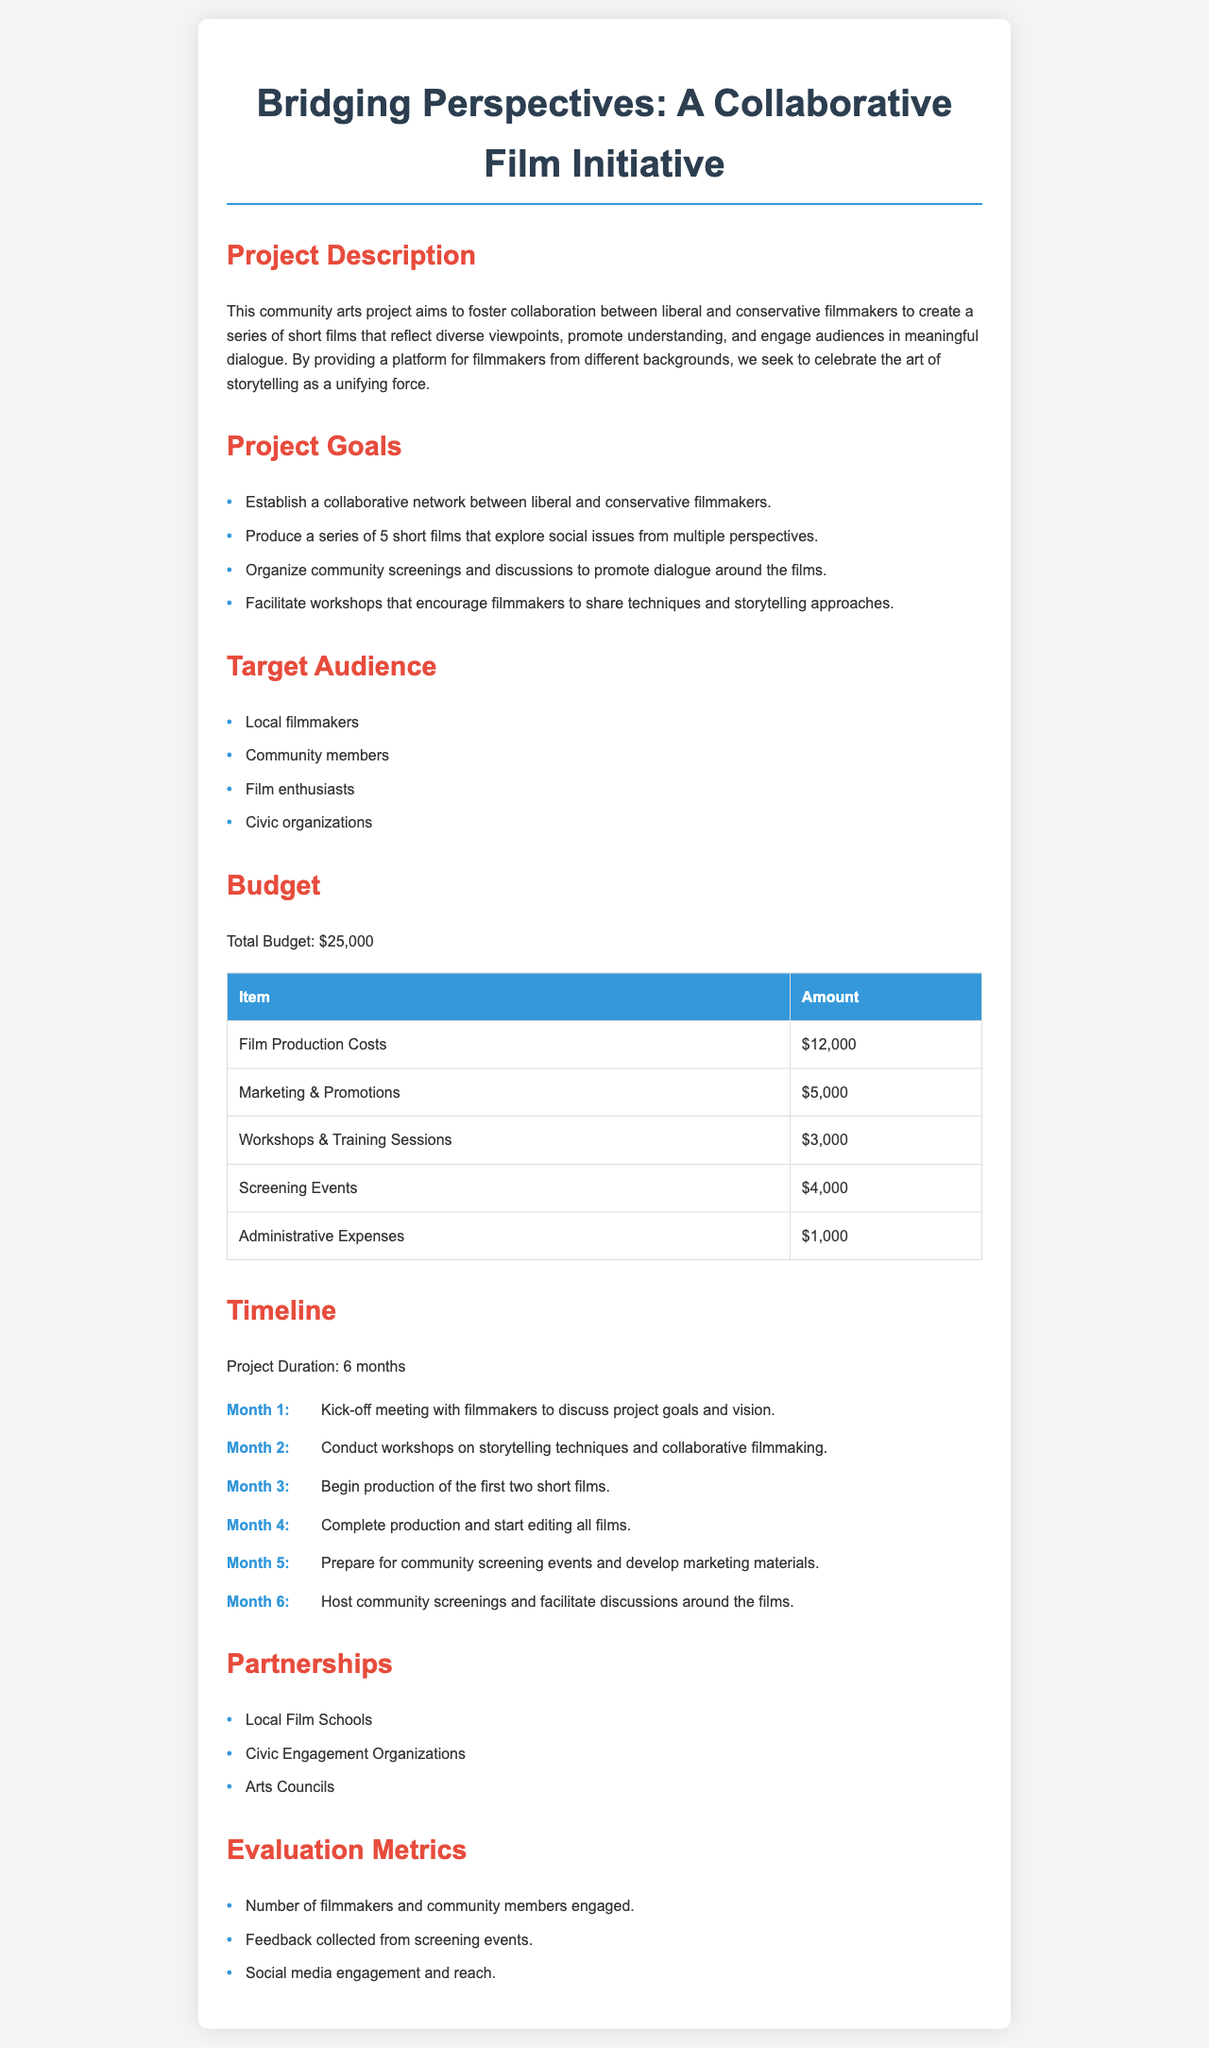What is the total budget? The total budget is stated clearly in the document as $25,000.
Answer: $25,000 How many short films will be produced? The document specifies that a series of 5 short films will be produced.
Answer: 5 What is the purpose of the community screenings? The purpose of the community screenings is to promote dialogue around the films.
Answer: Promote dialogue What month will the kick-off meeting take place? The kick-off meeting is scheduled for Month 1 as outlined in the timeline section.
Answer: Month 1 What types of organizations will be partnered with? The document mentions partnerships with local film schools, civic engagement organizations, and arts councils.
Answer: Local Film Schools, Civic Engagement Organizations, Arts Councils How much will be allocated for workshops and training sessions? The budget item for workshops and training sessions is $3,000 as indicated in the budget table.
Answer: $3,000 What activity will occur in Month 4? In Month 4, the production will be completed, and editing of all films will start.
Answer: Complete production and start editing How will the project evaluate its success? The project will evaluate its success based on the number of engaged filmmakers and community members, feedback from screening events, and social media engagement.
Answer: Number of filmmakers and community members engaged What is the goal of the project? One of the main goals of the project is to establish a collaborative network between liberal and conservative filmmakers.
Answer: Establish a collaborative network 